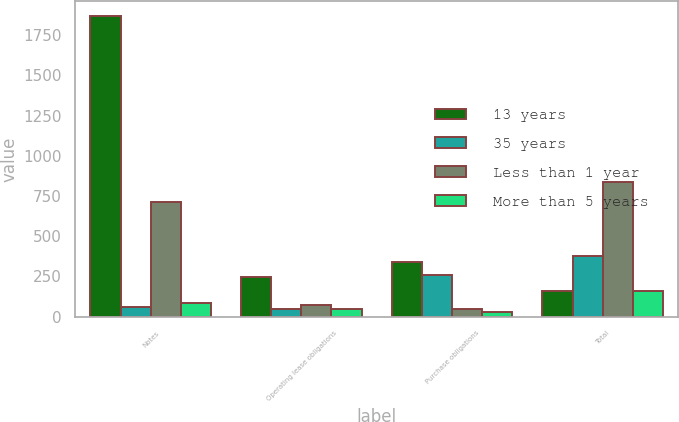Convert chart to OTSL. <chart><loc_0><loc_0><loc_500><loc_500><stacked_bar_chart><ecel><fcel>Notes<fcel>Operating lease obligations<fcel>Purchase obligations<fcel>Total<nl><fcel>13 years<fcel>1869.5<fcel>246.1<fcel>342.2<fcel>159.5<nl><fcel>35 years<fcel>62.3<fcel>47.3<fcel>256.4<fcel>377.4<nl><fcel>Less than 1 year<fcel>714.8<fcel>73<fcel>46.5<fcel>836.1<nl><fcel>More than 5 years<fcel>85.5<fcel>46.7<fcel>27.3<fcel>159.5<nl></chart> 